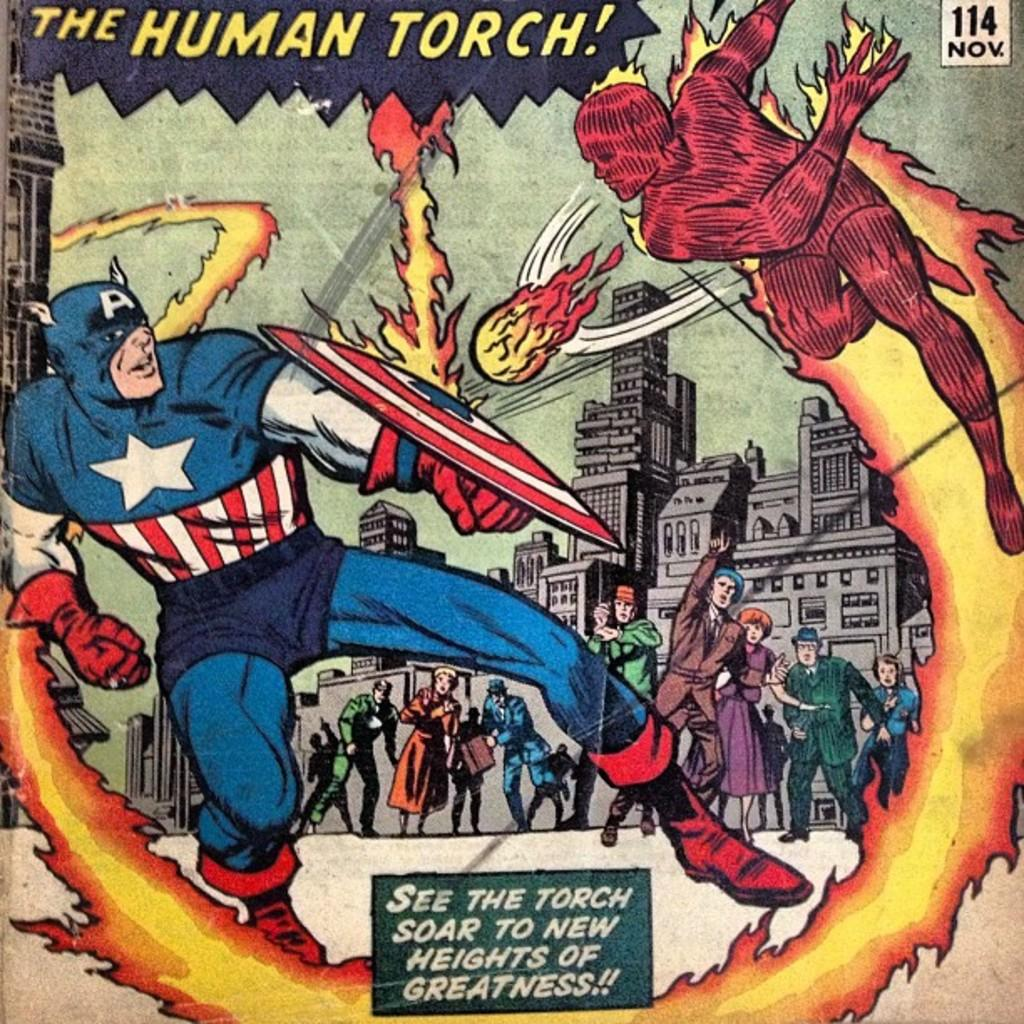<image>
Render a clear and concise summary of the photo. A scene from a comic book shows The Human Torch hurling fireballs at Captain America. 